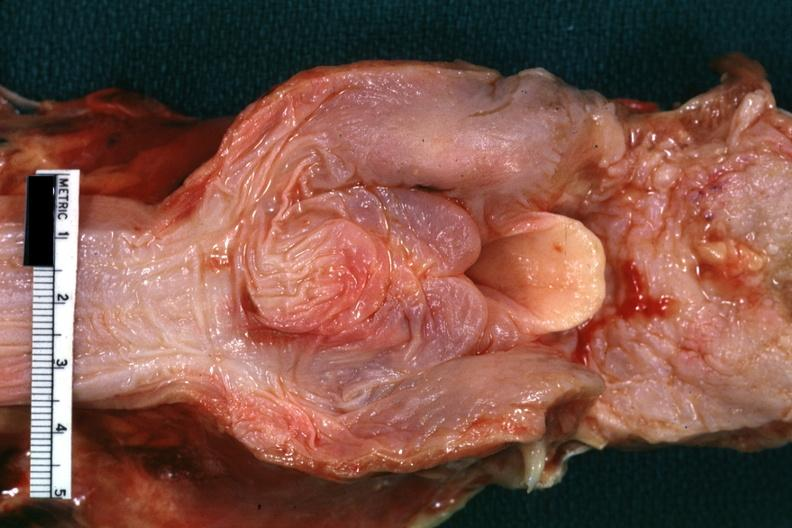s oral present?
Answer the question using a single word or phrase. Yes 